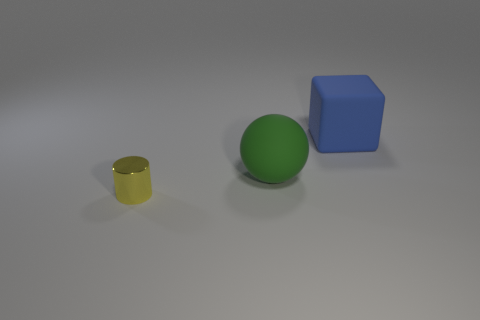Add 1 big green rubber things. How many objects exist? 4 Subtract all balls. How many objects are left? 2 Add 1 big things. How many big things are left? 3 Add 2 tiny purple shiny cubes. How many tiny purple shiny cubes exist? 2 Subtract 0 blue spheres. How many objects are left? 3 Subtract all blue rubber things. Subtract all big green spheres. How many objects are left? 1 